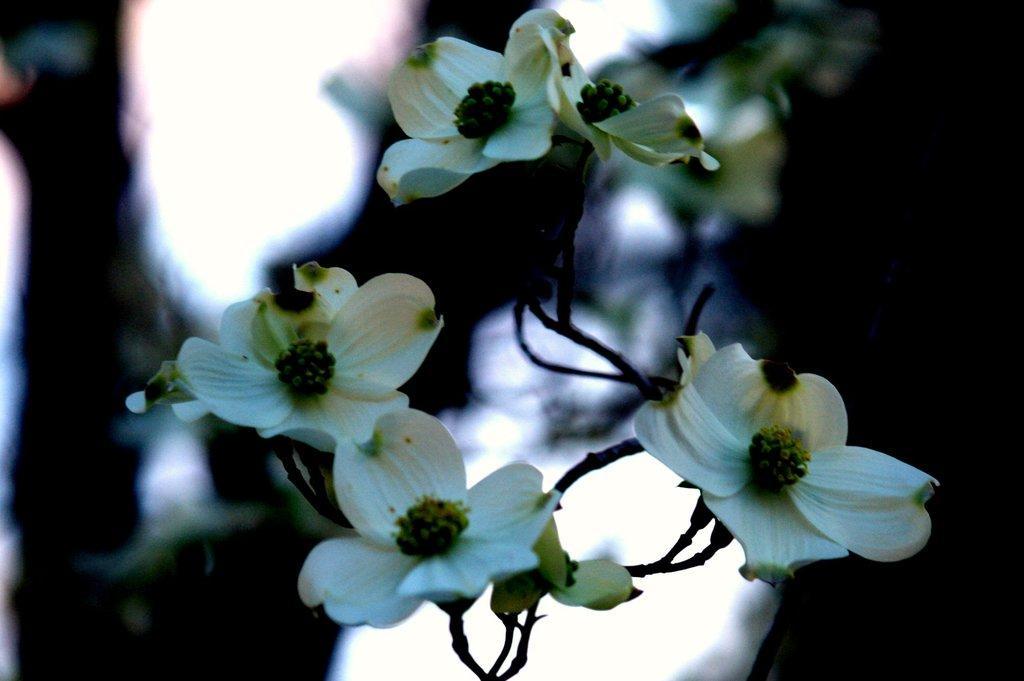In one or two sentences, can you explain what this image depicts? In this image I can see some flowers to the stem of a plant. 